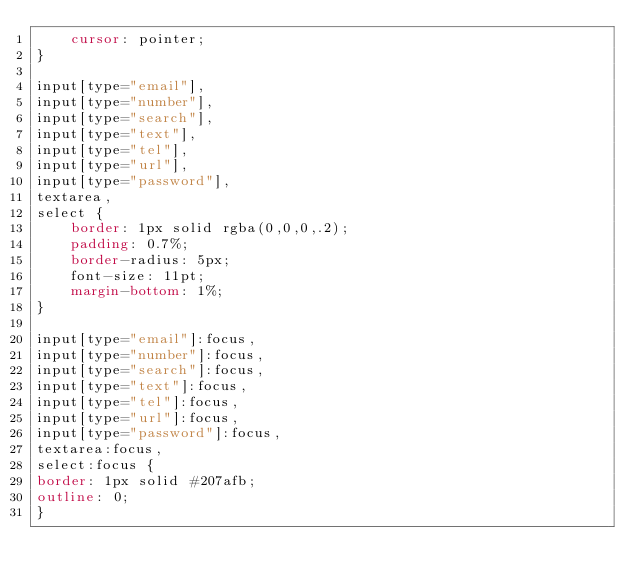Convert code to text. <code><loc_0><loc_0><loc_500><loc_500><_CSS_>    cursor: pointer;
}

input[type="email"],
input[type="number"],
input[type="search"],
input[type="text"],
input[type="tel"],
input[type="url"],
input[type="password"],
textarea,
select {
    border: 1px solid rgba(0,0,0,.2);
    padding: 0.7%;
    border-radius: 5px;
    font-size: 11pt;
    margin-bottom: 1%;
}

input[type="email"]:focus,
input[type="number"]:focus,
input[type="search"]:focus,
input[type="text"]:focus,
input[type="tel"]:focus,
input[type="url"]:focus,
input[type="password"]:focus,
textarea:focus,
select:focus {
border: 1px solid #207afb;
outline: 0;
}
</code> 